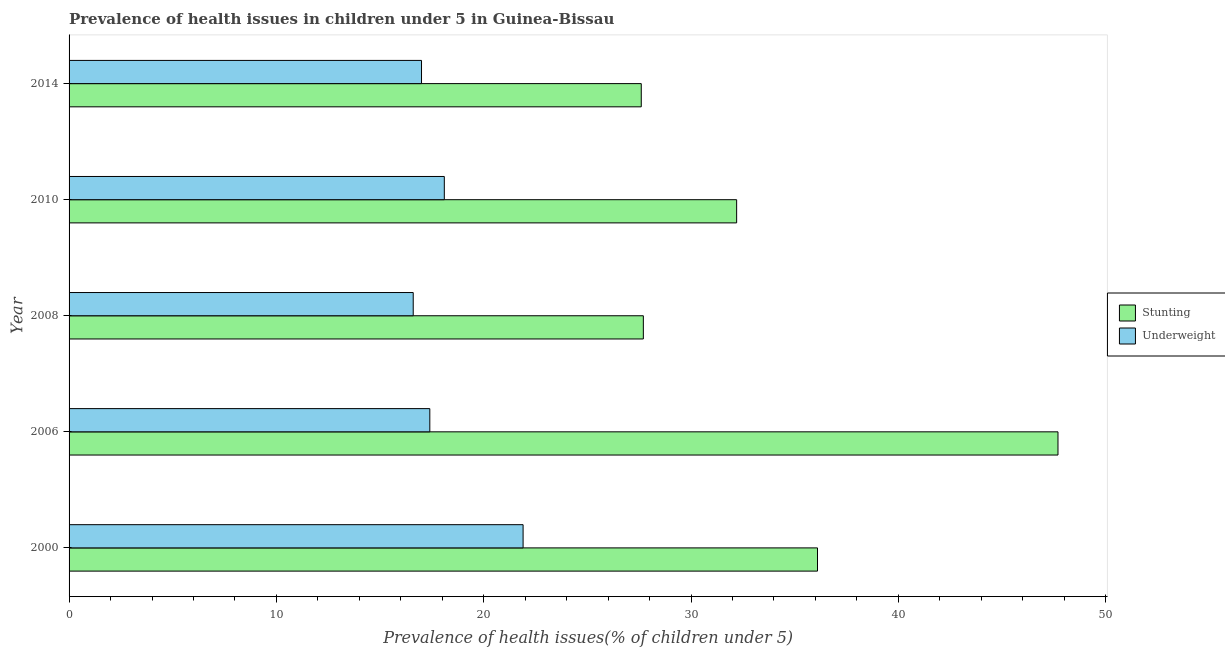How many groups of bars are there?
Your answer should be very brief. 5. Are the number of bars per tick equal to the number of legend labels?
Give a very brief answer. Yes. Are the number of bars on each tick of the Y-axis equal?
Your response must be concise. Yes. How many bars are there on the 4th tick from the top?
Make the answer very short. 2. How many bars are there on the 1st tick from the bottom?
Your answer should be compact. 2. What is the label of the 5th group of bars from the top?
Your answer should be compact. 2000. What is the percentage of underweight children in 2006?
Give a very brief answer. 17.4. Across all years, what is the maximum percentage of underweight children?
Keep it short and to the point. 21.9. Across all years, what is the minimum percentage of underweight children?
Provide a short and direct response. 16.6. In which year was the percentage of underweight children maximum?
Your answer should be compact. 2000. What is the total percentage of underweight children in the graph?
Offer a very short reply. 91. What is the difference between the percentage of stunted children in 2000 and the percentage of underweight children in 2008?
Make the answer very short. 19.5. What is the average percentage of underweight children per year?
Provide a succinct answer. 18.2. In the year 2006, what is the difference between the percentage of stunted children and percentage of underweight children?
Give a very brief answer. 30.3. What is the ratio of the percentage of stunted children in 2000 to that in 2008?
Provide a succinct answer. 1.3. Is the difference between the percentage of stunted children in 2000 and 2014 greater than the difference between the percentage of underweight children in 2000 and 2014?
Your answer should be compact. Yes. What is the difference between the highest and the second highest percentage of underweight children?
Keep it short and to the point. 3.8. What is the difference between the highest and the lowest percentage of stunted children?
Ensure brevity in your answer.  20.1. In how many years, is the percentage of underweight children greater than the average percentage of underweight children taken over all years?
Make the answer very short. 1. Is the sum of the percentage of underweight children in 2006 and 2014 greater than the maximum percentage of stunted children across all years?
Keep it short and to the point. No. What does the 1st bar from the top in 2010 represents?
Make the answer very short. Underweight. What does the 2nd bar from the bottom in 2006 represents?
Your response must be concise. Underweight. Are all the bars in the graph horizontal?
Offer a very short reply. Yes. How many years are there in the graph?
Make the answer very short. 5. What is the difference between two consecutive major ticks on the X-axis?
Your answer should be very brief. 10. Does the graph contain any zero values?
Offer a very short reply. No. Does the graph contain grids?
Offer a very short reply. No. Where does the legend appear in the graph?
Make the answer very short. Center right. What is the title of the graph?
Your answer should be compact. Prevalence of health issues in children under 5 in Guinea-Bissau. Does "Broad money growth" appear as one of the legend labels in the graph?
Offer a terse response. No. What is the label or title of the X-axis?
Give a very brief answer. Prevalence of health issues(% of children under 5). What is the Prevalence of health issues(% of children under 5) of Stunting in 2000?
Give a very brief answer. 36.1. What is the Prevalence of health issues(% of children under 5) in Underweight in 2000?
Give a very brief answer. 21.9. What is the Prevalence of health issues(% of children under 5) in Stunting in 2006?
Offer a terse response. 47.7. What is the Prevalence of health issues(% of children under 5) of Underweight in 2006?
Offer a terse response. 17.4. What is the Prevalence of health issues(% of children under 5) in Stunting in 2008?
Provide a short and direct response. 27.7. What is the Prevalence of health issues(% of children under 5) of Underweight in 2008?
Provide a short and direct response. 16.6. What is the Prevalence of health issues(% of children under 5) in Stunting in 2010?
Provide a short and direct response. 32.2. What is the Prevalence of health issues(% of children under 5) of Underweight in 2010?
Your answer should be compact. 18.1. What is the Prevalence of health issues(% of children under 5) of Stunting in 2014?
Make the answer very short. 27.6. What is the Prevalence of health issues(% of children under 5) in Underweight in 2014?
Provide a short and direct response. 17. Across all years, what is the maximum Prevalence of health issues(% of children under 5) in Stunting?
Ensure brevity in your answer.  47.7. Across all years, what is the maximum Prevalence of health issues(% of children under 5) in Underweight?
Make the answer very short. 21.9. Across all years, what is the minimum Prevalence of health issues(% of children under 5) of Stunting?
Make the answer very short. 27.6. Across all years, what is the minimum Prevalence of health issues(% of children under 5) in Underweight?
Keep it short and to the point. 16.6. What is the total Prevalence of health issues(% of children under 5) of Stunting in the graph?
Offer a terse response. 171.3. What is the total Prevalence of health issues(% of children under 5) in Underweight in the graph?
Offer a very short reply. 91. What is the difference between the Prevalence of health issues(% of children under 5) of Stunting in 2000 and that in 2006?
Make the answer very short. -11.6. What is the difference between the Prevalence of health issues(% of children under 5) of Underweight in 2000 and that in 2006?
Provide a succinct answer. 4.5. What is the difference between the Prevalence of health issues(% of children under 5) in Stunting in 2000 and that in 2008?
Your response must be concise. 8.4. What is the difference between the Prevalence of health issues(% of children under 5) of Underweight in 2000 and that in 2008?
Keep it short and to the point. 5.3. What is the difference between the Prevalence of health issues(% of children under 5) in Stunting in 2000 and that in 2010?
Provide a succinct answer. 3.9. What is the difference between the Prevalence of health issues(% of children under 5) of Stunting in 2006 and that in 2008?
Give a very brief answer. 20. What is the difference between the Prevalence of health issues(% of children under 5) in Stunting in 2006 and that in 2010?
Ensure brevity in your answer.  15.5. What is the difference between the Prevalence of health issues(% of children under 5) in Underweight in 2006 and that in 2010?
Your response must be concise. -0.7. What is the difference between the Prevalence of health issues(% of children under 5) of Stunting in 2006 and that in 2014?
Your response must be concise. 20.1. What is the difference between the Prevalence of health issues(% of children under 5) of Underweight in 2006 and that in 2014?
Ensure brevity in your answer.  0.4. What is the difference between the Prevalence of health issues(% of children under 5) in Underweight in 2008 and that in 2010?
Make the answer very short. -1.5. What is the difference between the Prevalence of health issues(% of children under 5) in Stunting in 2008 and that in 2014?
Make the answer very short. 0.1. What is the difference between the Prevalence of health issues(% of children under 5) in Stunting in 2010 and that in 2014?
Offer a very short reply. 4.6. What is the difference between the Prevalence of health issues(% of children under 5) in Underweight in 2010 and that in 2014?
Provide a short and direct response. 1.1. What is the difference between the Prevalence of health issues(% of children under 5) of Stunting in 2000 and the Prevalence of health issues(% of children under 5) of Underweight in 2014?
Offer a very short reply. 19.1. What is the difference between the Prevalence of health issues(% of children under 5) of Stunting in 2006 and the Prevalence of health issues(% of children under 5) of Underweight in 2008?
Give a very brief answer. 31.1. What is the difference between the Prevalence of health issues(% of children under 5) of Stunting in 2006 and the Prevalence of health issues(% of children under 5) of Underweight in 2010?
Your response must be concise. 29.6. What is the difference between the Prevalence of health issues(% of children under 5) in Stunting in 2006 and the Prevalence of health issues(% of children under 5) in Underweight in 2014?
Your answer should be very brief. 30.7. What is the difference between the Prevalence of health issues(% of children under 5) in Stunting in 2008 and the Prevalence of health issues(% of children under 5) in Underweight in 2010?
Offer a very short reply. 9.6. What is the difference between the Prevalence of health issues(% of children under 5) in Stunting in 2008 and the Prevalence of health issues(% of children under 5) in Underweight in 2014?
Provide a succinct answer. 10.7. What is the difference between the Prevalence of health issues(% of children under 5) in Stunting in 2010 and the Prevalence of health issues(% of children under 5) in Underweight in 2014?
Your answer should be very brief. 15.2. What is the average Prevalence of health issues(% of children under 5) in Stunting per year?
Provide a succinct answer. 34.26. What is the average Prevalence of health issues(% of children under 5) in Underweight per year?
Your answer should be compact. 18.2. In the year 2006, what is the difference between the Prevalence of health issues(% of children under 5) of Stunting and Prevalence of health issues(% of children under 5) of Underweight?
Offer a very short reply. 30.3. In the year 2008, what is the difference between the Prevalence of health issues(% of children under 5) of Stunting and Prevalence of health issues(% of children under 5) of Underweight?
Offer a terse response. 11.1. In the year 2014, what is the difference between the Prevalence of health issues(% of children under 5) of Stunting and Prevalence of health issues(% of children under 5) of Underweight?
Ensure brevity in your answer.  10.6. What is the ratio of the Prevalence of health issues(% of children under 5) of Stunting in 2000 to that in 2006?
Offer a very short reply. 0.76. What is the ratio of the Prevalence of health issues(% of children under 5) of Underweight in 2000 to that in 2006?
Offer a terse response. 1.26. What is the ratio of the Prevalence of health issues(% of children under 5) in Stunting in 2000 to that in 2008?
Your response must be concise. 1.3. What is the ratio of the Prevalence of health issues(% of children under 5) of Underweight in 2000 to that in 2008?
Give a very brief answer. 1.32. What is the ratio of the Prevalence of health issues(% of children under 5) of Stunting in 2000 to that in 2010?
Provide a succinct answer. 1.12. What is the ratio of the Prevalence of health issues(% of children under 5) in Underweight in 2000 to that in 2010?
Make the answer very short. 1.21. What is the ratio of the Prevalence of health issues(% of children under 5) in Stunting in 2000 to that in 2014?
Ensure brevity in your answer.  1.31. What is the ratio of the Prevalence of health issues(% of children under 5) in Underweight in 2000 to that in 2014?
Your answer should be compact. 1.29. What is the ratio of the Prevalence of health issues(% of children under 5) in Stunting in 2006 to that in 2008?
Give a very brief answer. 1.72. What is the ratio of the Prevalence of health issues(% of children under 5) in Underweight in 2006 to that in 2008?
Ensure brevity in your answer.  1.05. What is the ratio of the Prevalence of health issues(% of children under 5) of Stunting in 2006 to that in 2010?
Offer a terse response. 1.48. What is the ratio of the Prevalence of health issues(% of children under 5) of Underweight in 2006 to that in 2010?
Offer a very short reply. 0.96. What is the ratio of the Prevalence of health issues(% of children under 5) in Stunting in 2006 to that in 2014?
Provide a succinct answer. 1.73. What is the ratio of the Prevalence of health issues(% of children under 5) in Underweight in 2006 to that in 2014?
Your answer should be very brief. 1.02. What is the ratio of the Prevalence of health issues(% of children under 5) of Stunting in 2008 to that in 2010?
Offer a terse response. 0.86. What is the ratio of the Prevalence of health issues(% of children under 5) of Underweight in 2008 to that in 2010?
Make the answer very short. 0.92. What is the ratio of the Prevalence of health issues(% of children under 5) of Underweight in 2008 to that in 2014?
Offer a very short reply. 0.98. What is the ratio of the Prevalence of health issues(% of children under 5) in Stunting in 2010 to that in 2014?
Give a very brief answer. 1.17. What is the ratio of the Prevalence of health issues(% of children under 5) in Underweight in 2010 to that in 2014?
Offer a very short reply. 1.06. What is the difference between the highest and the lowest Prevalence of health issues(% of children under 5) in Stunting?
Provide a short and direct response. 20.1. What is the difference between the highest and the lowest Prevalence of health issues(% of children under 5) of Underweight?
Provide a short and direct response. 5.3. 